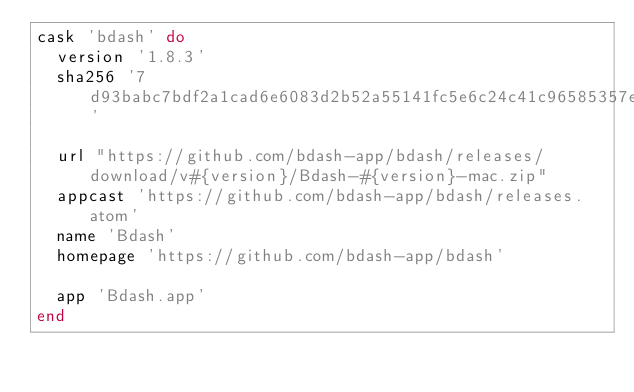<code> <loc_0><loc_0><loc_500><loc_500><_Ruby_>cask 'bdash' do
  version '1.8.3'
  sha256 '7d93babc7bdf2a1cad6e6083d2b52a55141fc5e6c24c41c96585357e84da5f04'

  url "https://github.com/bdash-app/bdash/releases/download/v#{version}/Bdash-#{version}-mac.zip"
  appcast 'https://github.com/bdash-app/bdash/releases.atom'
  name 'Bdash'
  homepage 'https://github.com/bdash-app/bdash'

  app 'Bdash.app'
end
</code> 